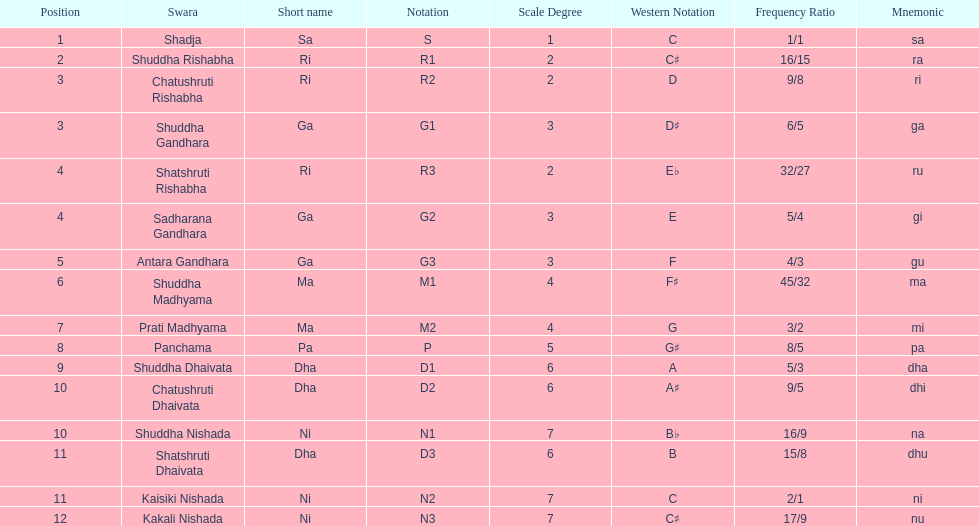What is the total number of positions listed? 16. 